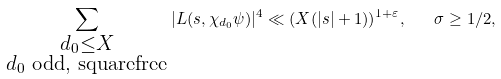Convert formula to latex. <formula><loc_0><loc_0><loc_500><loc_500>\sum _ { \substack { d _ { 0 } \leq X \\ d _ { 0 } \text { odd, squarefree} } } | L ( s , \chi _ { d _ { 0 } } \psi ) | ^ { 4 } \ll ( X ( | s | + 1 ) ) ^ { 1 + \varepsilon } , \quad \sigma \geq 1 / 2 ,</formula> 